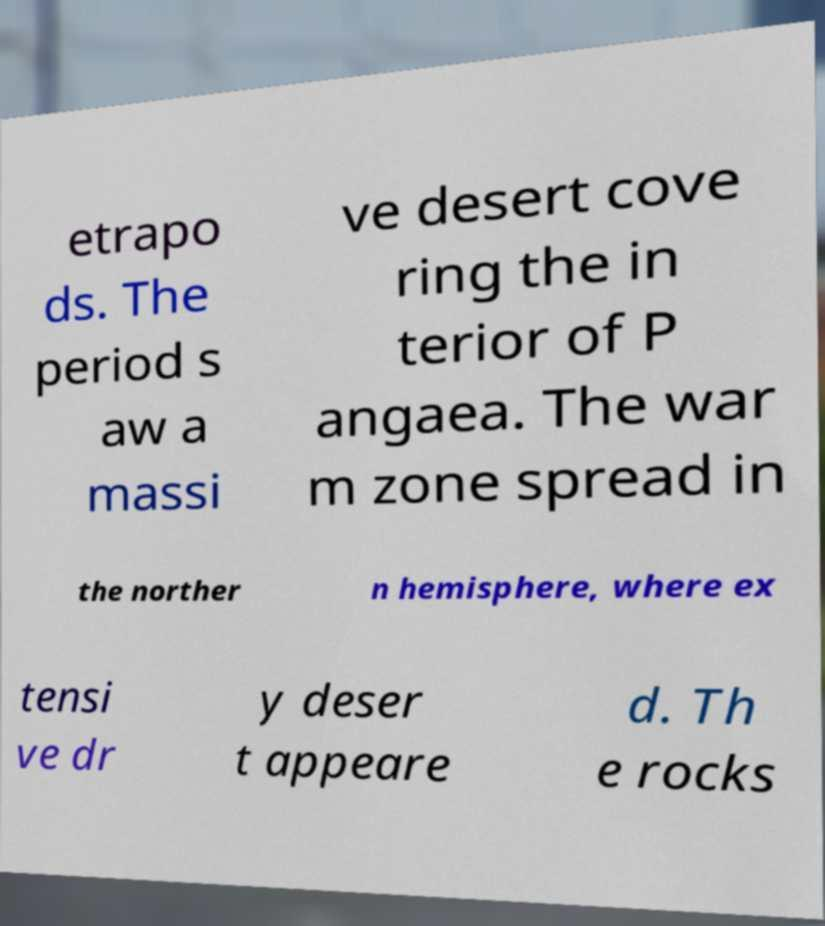Can you read and provide the text displayed in the image?This photo seems to have some interesting text. Can you extract and type it out for me? etrapo ds. The period s aw a massi ve desert cove ring the in terior of P angaea. The war m zone spread in the norther n hemisphere, where ex tensi ve dr y deser t appeare d. Th e rocks 